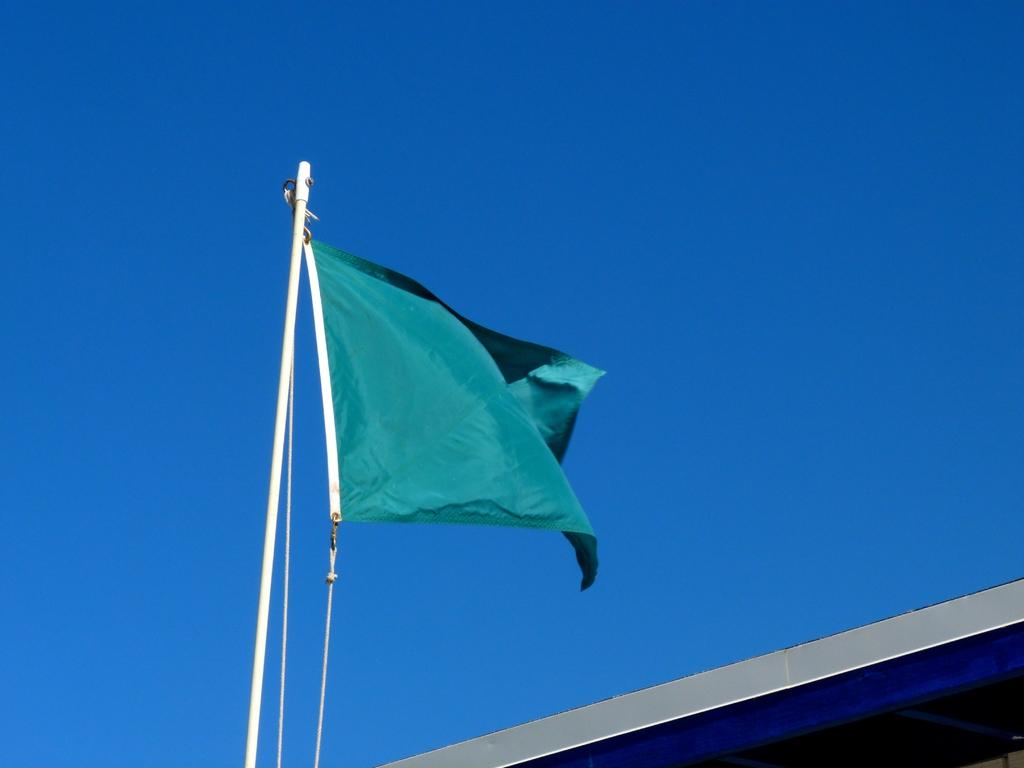What can be seen flying in the image? There is a flag in the image. What is the flag attached to? The flag is on a white color pole. What type of structure is visible in the image? There is a building visible in the image. What color is predominant in the background of the image? The background of the image is blue. What type of grip does the flag have on the breakfast in the image? There is no breakfast present in the image, and the flag is not interacting with any object in a way that would require a grip. 